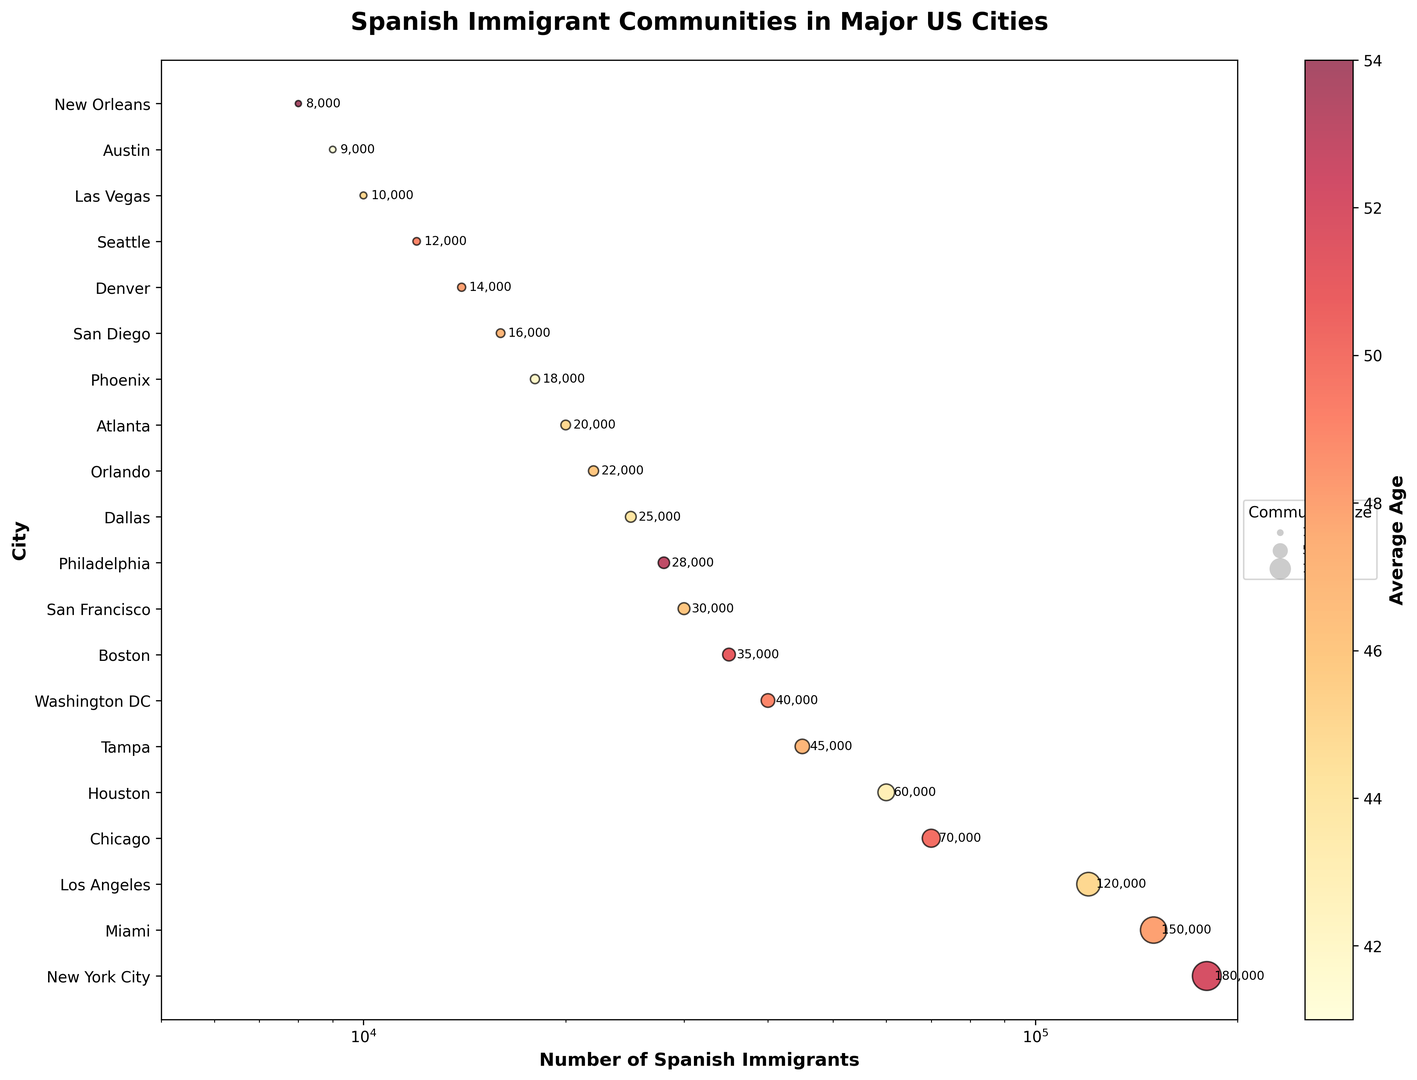Which city has the largest Spanish immigrant community? Looking at the largest bubble, it represents New York City with 180,000 Spanish immigrants.
Answer: New York City What is the average age of the Spanish immigrant community in New York City? The bubble for New York City is colored corresponding to an average age of 52, indicated by the color bar.
Answer: 52 Which city has the highest average age among Spanish immigrants? The darkest color representing the highest average age is for New Orleans, with an average age of 54.
Answer: New Orleans Comparing Miami and Houston, which city has a larger Spanish immigrant community? Miami has a significantly larger bubble compared to Houston. Miami has 150,000 Spanish immigrants, while Houston has 60,000.
Answer: Miami What is the total number of Spanish immigrants in Chicago and Boston combined? Chicago has 70,000 Spanish immigrants and Boston has 35,000. Summing them up: 70,000 + 35,000 = 105,000.
Answer: 105,000 Which city has an average age closest to 50 years? Chicago has an average age of 50 years, indicated by the color and the data for the bubble.
Answer: Chicago Between Tampa and Orlando, which city has a higher average age for its Spanish immigrant community? Tampa's average age is 47 while Orlando's is 46, indicated by their bubble colors.
Answer: Tampa Which three cities have the smallest Spanish immigrant communities and what are their average ages? Austin (9,000, 41), New Orleans (8,000, 54), and Las Vegas (10,000, 45), read from the smallest bubbles.
Answer: Austin, New Orleans, Las Vegas What is the difference in the number of Spanish immigrants between Los Angeles and Philadelphia? Los Angeles has 120,000 and Philadelphia 28,000. The difference is 120,000 - 28,000 = 92,000.
Answer: 92,000 Do more cities in the Northeast or Southeast have an average age above 50 years? In the Northeast, New York City (52) and Philadelphia (53) are above 50. In the Southeast, no cities have an average age above 50. Therefore, the Northeast has more.
Answer: Northeast 